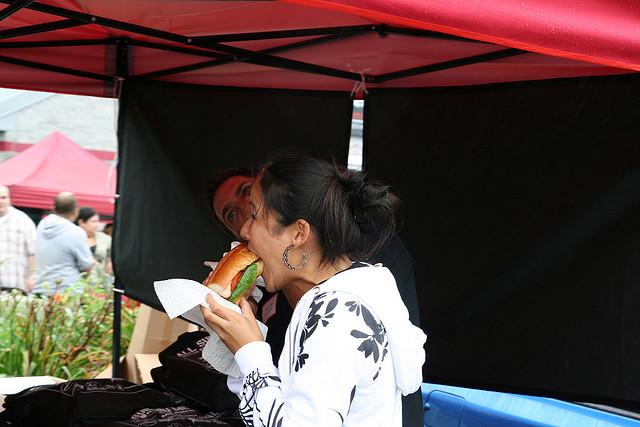Who is already eating?
Short answer required. Woman. Does this woman have an earring?
Be succinct. Yes. Is the girl biting off more than she can chew?
Give a very brief answer. Yes. What kind of materials is it that makes up this red tent?
Keep it brief. Canvas. Would you call this a photobomb?
Write a very short answer. Yes. What food item are the people consuming?
Answer briefly. Sandwich. 